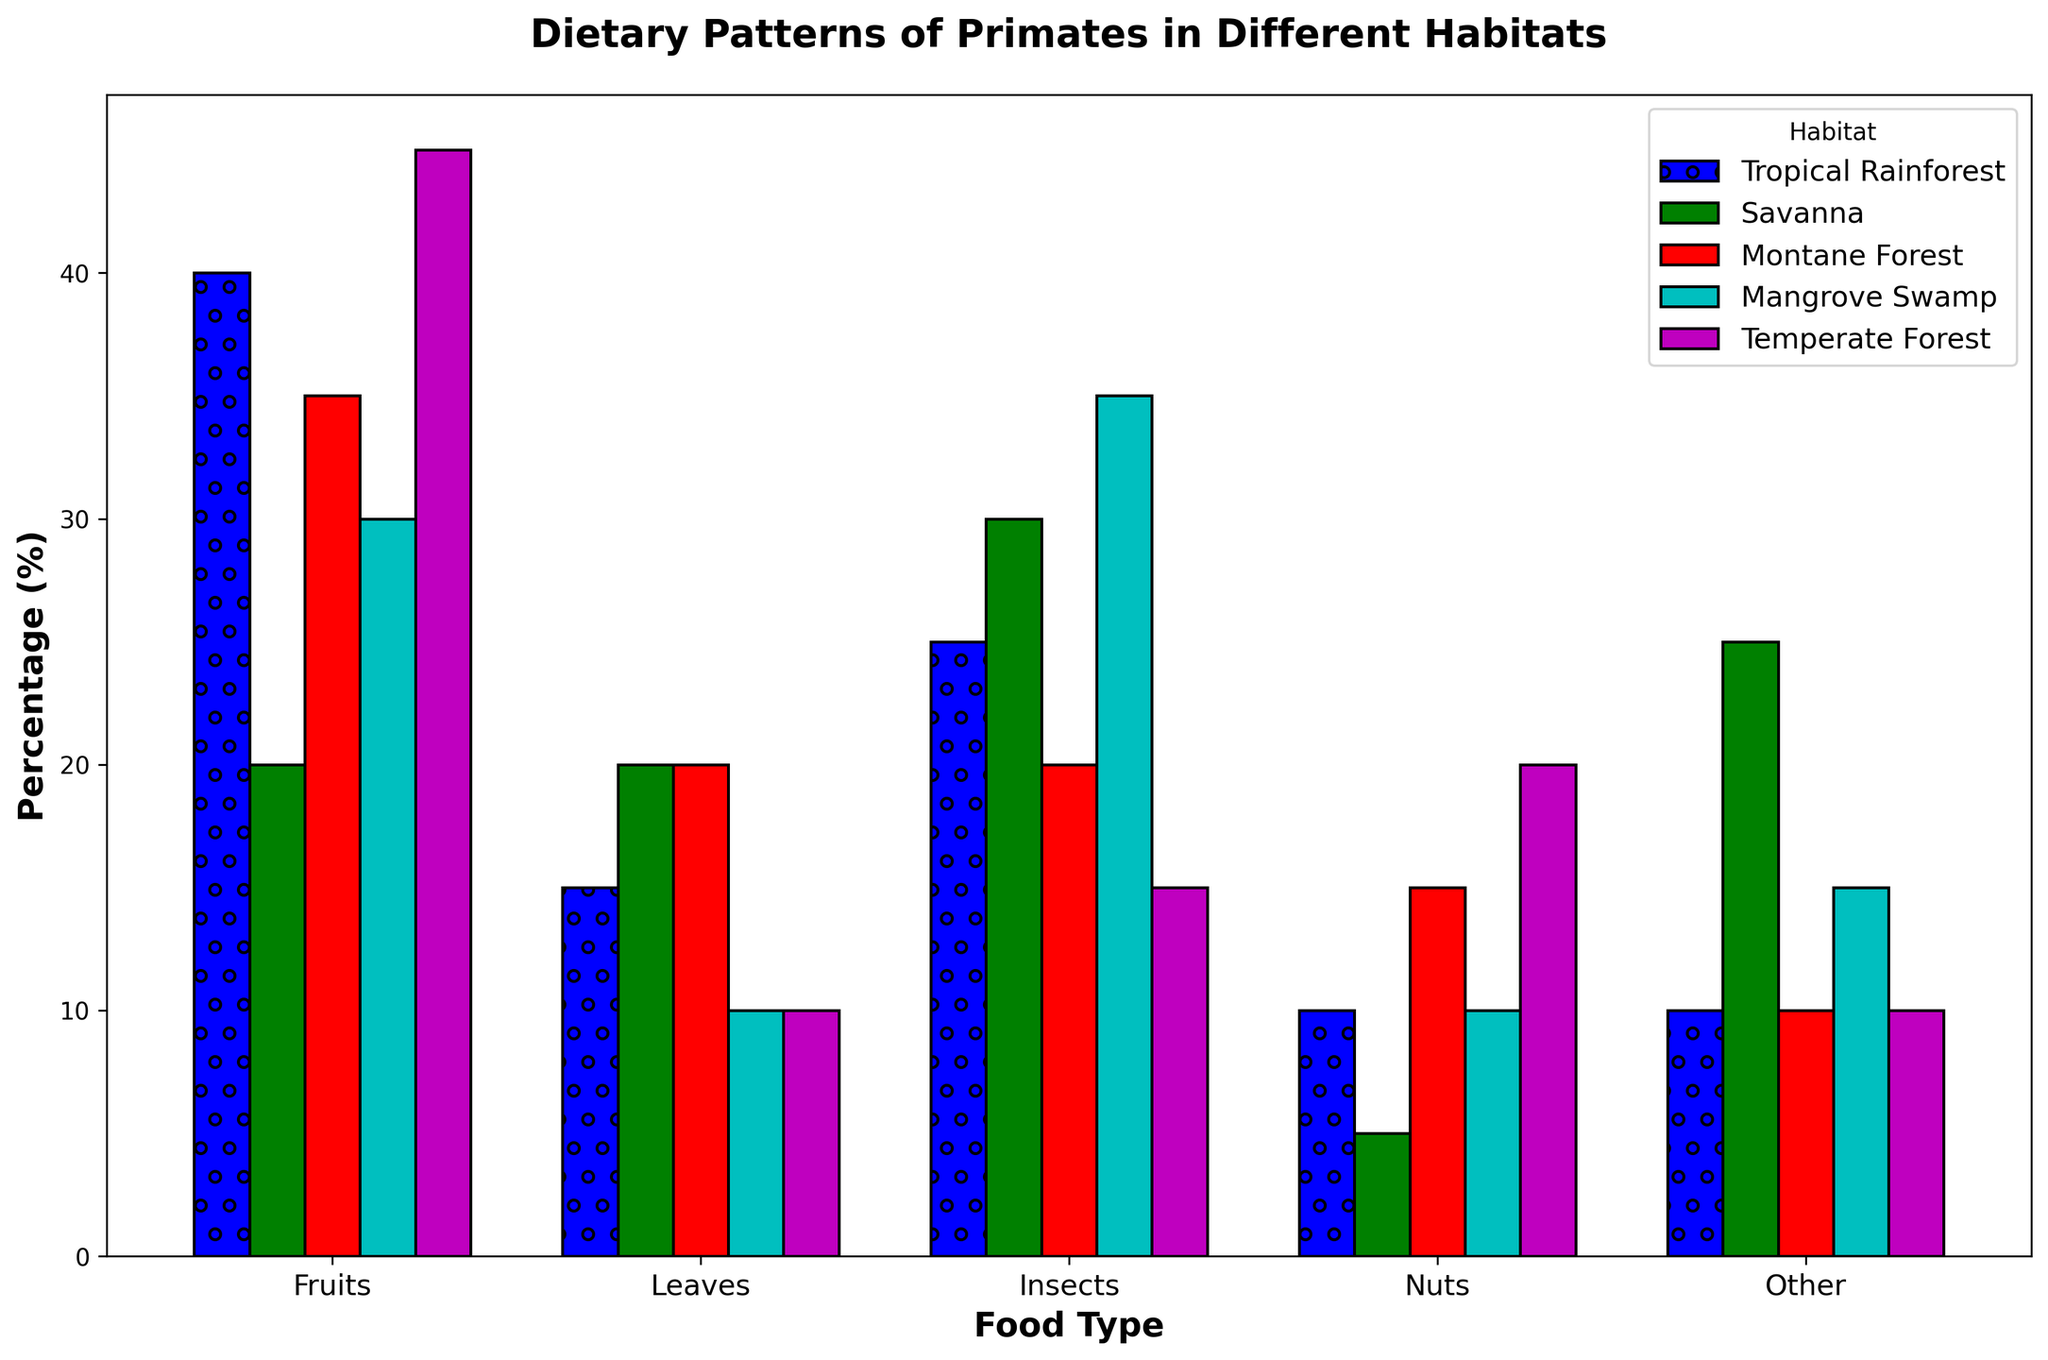What food type has the highest percentage in the temperate forest habitat? Visually identify the tallest bar corresponding to the temperate forest habitat. The bar for fruits is the highest in the temperate forest habitat.
Answer: Fruits Which habitat has the lowest percentage of nuts? Visually compare the heights of the bars labeled "Nuts" across all habitats. The bar for nuts in the savanna is the shortest.
Answer: Savanna What is the total percentage of non-fruit food types in the tropical rainforest habitat? The non-fruit food types are leaves, insects, nuts, and other. Add their percentages: 25 (leaves) + 15 (insects) + 10 (nuts) + 10 (other) = 60.
Answer: 60 Which food type shows the least variation in percentage across different habitats? Visually compare the heights of bars for each food type across all habitats. The bars for insects appear to be most consistent across different habitats.
Answer: Insects Compare the percentage of leaves in the tropical rainforest and mangrove swamp habitats. Which habitat has a higher percentage and by how much? Visually compare the heights of the bars labeled "Leaves" in the tropical rainforest and mangrove swamp. Leaves in the tropical rainforest are 25% and in the mangrove swamp are 35%. 35 - 25 = 10.
Answer: Mangrove swamp by 10 What is the average percentage of fruits across all habitats? Add the percentages of fruits in all habitats and divide by the number of habitats: (40 + 20 + 35 + 30 + 45) / 5 = 170 / 5 = 34.
Answer: 34 Comparing insects and other food types in the savanna habitat, which has a higher percentage and by how much? Visually compare the heights of the bars labeled "Insects" and "Other" in the savanna habitat. Insects in the savanna are 20% and other is 25%. 25 - 20 = 5.
Answer: Other by 5 Which habitat shows the highest overall diversity in diet (i.e., highest spread or variety of food types)? Visually inspect and compare the variability in bar heights across different food types for each habitat. The savanna habitat shows a high spread across all food types.
Answer: Savanna Which two habitats have the most similar dietary patterns based on the grouping of the bars? Visually compare the grouped bars for each habitat to identify which two appear most similar in the distribution of food types. The tropical rainforest and temperate forest habitats have similar profiles.
Answer: Tropical rainforest and temperate forest Which food type has the highest average percentage across all habitats? Add the percentages for each food type across all habitats, calculate the average for each, and compare: Fruits (40+20+35+30+45)/5 = 34, Leaves = 25, Insects = 15, Nuts = 12, Other = 14. Fruits have the highest average.
Answer: Fruits 